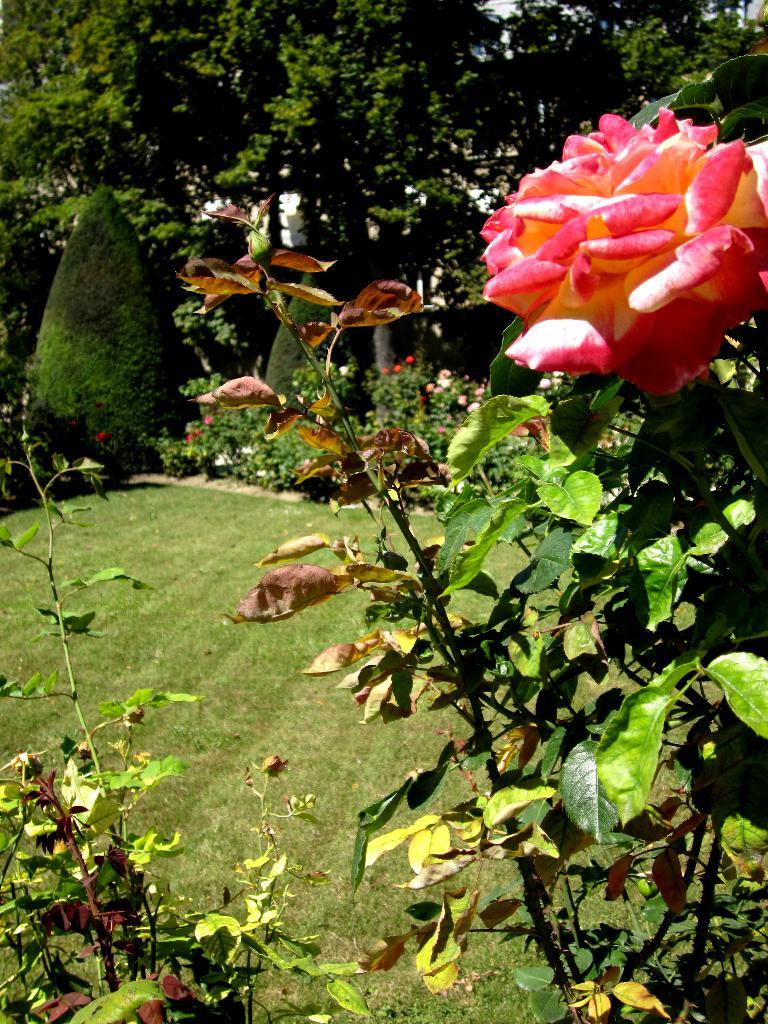What is the color of the flower in the image? The flower in the image is pink and cream colored. What can be seen in the background of the image? In the background of the image, there are flowers in multi color, plants in green color, trees in green color, and a building in white color. How many different colors are present in the flowers in the background? The flowers in the background are in multi color, which means there are multiple colors present. What is the color of the plants and trees in the background? The plants and trees in the background are green colored. Can you describe the experience of the sack in the image? There is no sack present in the image, so it is not possible to describe any experience related to it. 